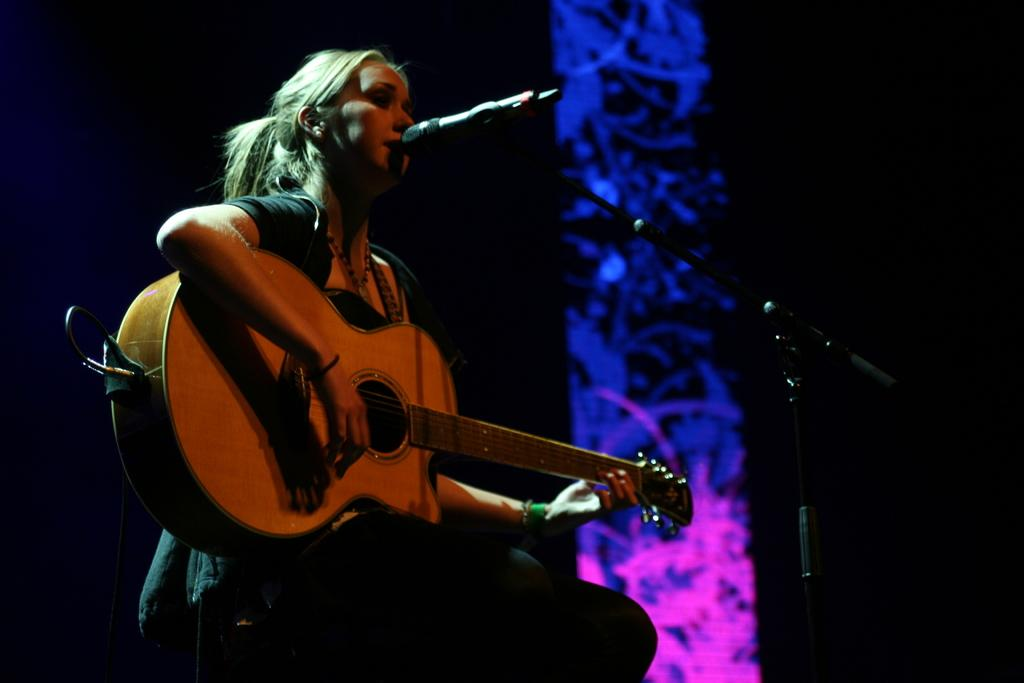Who is the main subject in the image? There is a woman in the image. What is the woman holding in the image? The woman is holding a guitar. What is the woman doing with the guitar? The woman is playing the guitar. What else is the woman doing in the image? The woman is singing into a microphone. What type of parcel is the woman holding in the image? There is no parcel present in the image; the woman is holding a guitar. Can you tell me how many zippers are visible on the woman's clothing in the image? There is no mention of zippers or any specific clothing details in the image. 